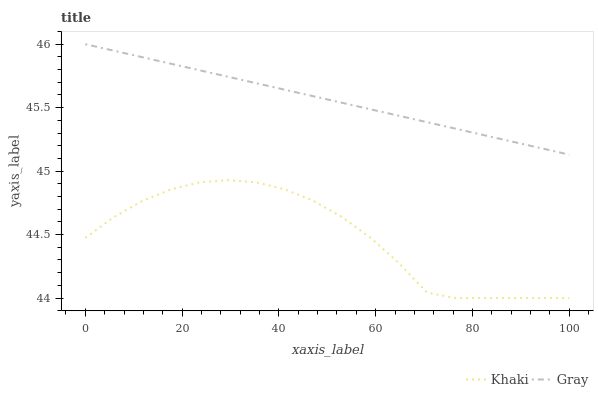Does Khaki have the minimum area under the curve?
Answer yes or no. Yes. Does Gray have the maximum area under the curve?
Answer yes or no. Yes. Does Khaki have the maximum area under the curve?
Answer yes or no. No. Is Gray the smoothest?
Answer yes or no. Yes. Is Khaki the roughest?
Answer yes or no. Yes. Is Khaki the smoothest?
Answer yes or no. No. Does Khaki have the lowest value?
Answer yes or no. Yes. Does Gray have the highest value?
Answer yes or no. Yes. Does Khaki have the highest value?
Answer yes or no. No. Is Khaki less than Gray?
Answer yes or no. Yes. Is Gray greater than Khaki?
Answer yes or no. Yes. Does Khaki intersect Gray?
Answer yes or no. No. 